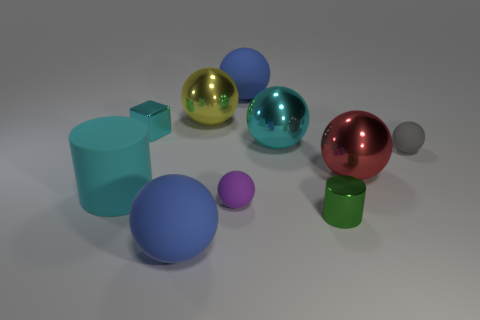How many cyan cylinders are made of the same material as the block?
Provide a short and direct response. 0. There is a tiny cube that is made of the same material as the big red sphere; what is its color?
Make the answer very short. Cyan. Is the number of cyan things less than the number of large things?
Your answer should be compact. Yes. What is the material of the tiny thing that is left of the blue object in front of the large rubber ball that is behind the yellow metallic object?
Provide a short and direct response. Metal. What is the material of the small cyan block?
Ensure brevity in your answer.  Metal. There is a rubber sphere that is behind the tiny cube; is it the same color as the large matte ball left of the yellow shiny object?
Your response must be concise. Yes. Is the number of green shiny blocks greater than the number of yellow objects?
Make the answer very short. No. What number of tiny things are the same color as the big cylinder?
Your answer should be compact. 1. What is the color of the other small object that is the same shape as the tiny gray object?
Keep it short and to the point. Purple. What is the big ball that is both in front of the gray matte thing and on the right side of the yellow metal ball made of?
Give a very brief answer. Metal. 